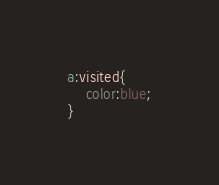Convert code to text. <code><loc_0><loc_0><loc_500><loc_500><_CSS_>a:visited{
    color:blue;
}

</code> 